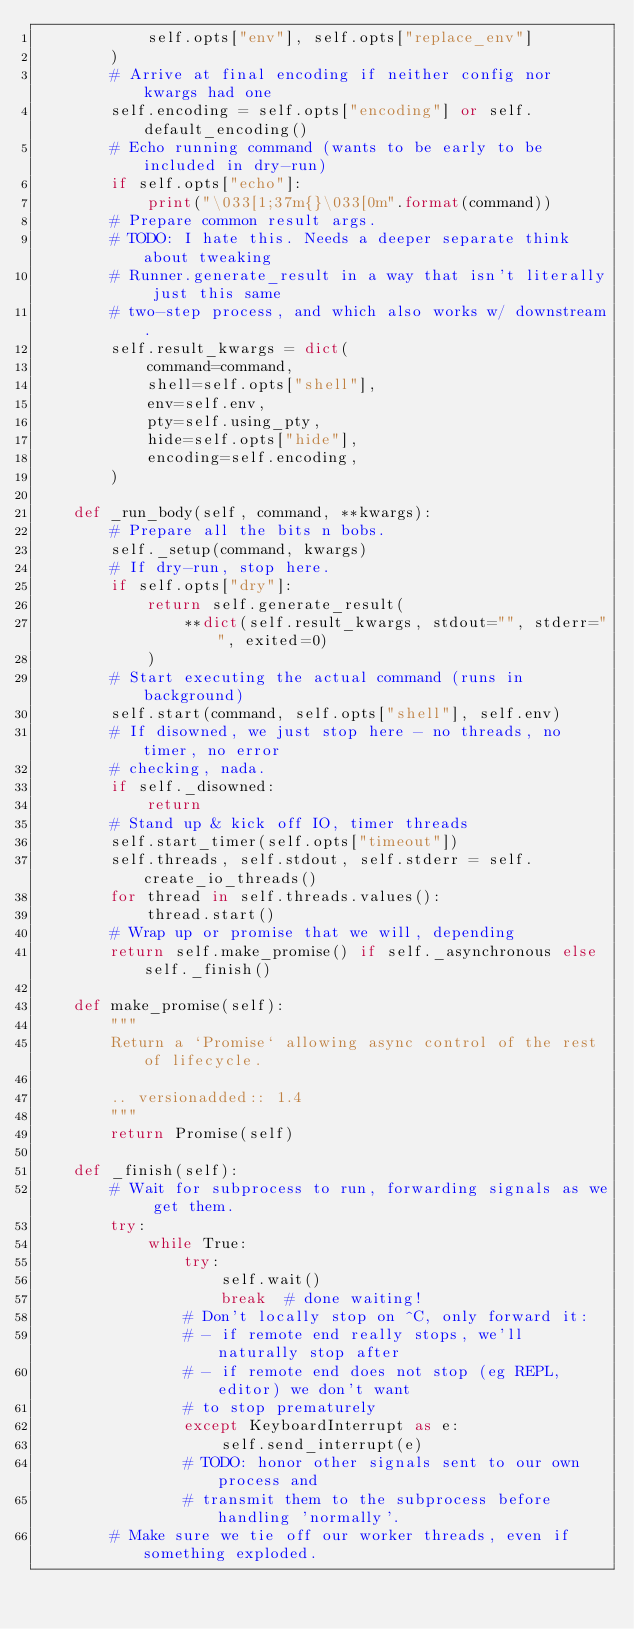<code> <loc_0><loc_0><loc_500><loc_500><_Python_>            self.opts["env"], self.opts["replace_env"]
        )
        # Arrive at final encoding if neither config nor kwargs had one
        self.encoding = self.opts["encoding"] or self.default_encoding()
        # Echo running command (wants to be early to be included in dry-run)
        if self.opts["echo"]:
            print("\033[1;37m{}\033[0m".format(command))
        # Prepare common result args.
        # TODO: I hate this. Needs a deeper separate think about tweaking
        # Runner.generate_result in a way that isn't literally just this same
        # two-step process, and which also works w/ downstream.
        self.result_kwargs = dict(
            command=command,
            shell=self.opts["shell"],
            env=self.env,
            pty=self.using_pty,
            hide=self.opts["hide"],
            encoding=self.encoding,
        )

    def _run_body(self, command, **kwargs):
        # Prepare all the bits n bobs.
        self._setup(command, kwargs)
        # If dry-run, stop here.
        if self.opts["dry"]:
            return self.generate_result(
                **dict(self.result_kwargs, stdout="", stderr="", exited=0)
            )
        # Start executing the actual command (runs in background)
        self.start(command, self.opts["shell"], self.env)
        # If disowned, we just stop here - no threads, no timer, no error
        # checking, nada.
        if self._disowned:
            return
        # Stand up & kick off IO, timer threads
        self.start_timer(self.opts["timeout"])
        self.threads, self.stdout, self.stderr = self.create_io_threads()
        for thread in self.threads.values():
            thread.start()
        # Wrap up or promise that we will, depending
        return self.make_promise() if self._asynchronous else self._finish()

    def make_promise(self):
        """
        Return a `Promise` allowing async control of the rest of lifecycle.

        .. versionadded:: 1.4
        """
        return Promise(self)

    def _finish(self):
        # Wait for subprocess to run, forwarding signals as we get them.
        try:
            while True:
                try:
                    self.wait()
                    break  # done waiting!
                # Don't locally stop on ^C, only forward it:
                # - if remote end really stops, we'll naturally stop after
                # - if remote end does not stop (eg REPL, editor) we don't want
                # to stop prematurely
                except KeyboardInterrupt as e:
                    self.send_interrupt(e)
                # TODO: honor other signals sent to our own process and
                # transmit them to the subprocess before handling 'normally'.
        # Make sure we tie off our worker threads, even if something exploded.</code> 